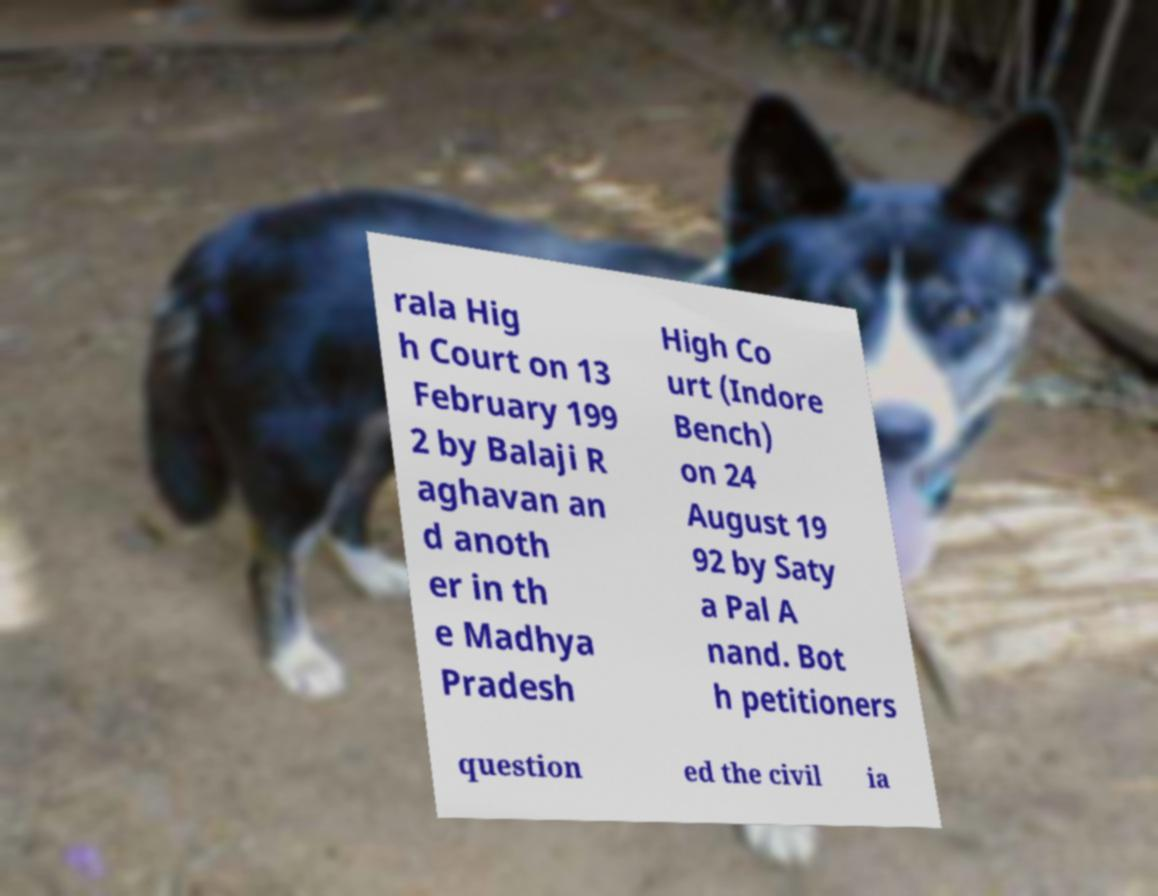What messages or text are displayed in this image? I need them in a readable, typed format. rala Hig h Court on 13 February 199 2 by Balaji R aghavan an d anoth er in th e Madhya Pradesh High Co urt (Indore Bench) on 24 August 19 92 by Saty a Pal A nand. Bot h petitioners question ed the civil ia 